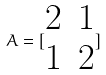<formula> <loc_0><loc_0><loc_500><loc_500>A = [ \begin{matrix} 2 & 1 \\ 1 & 2 \end{matrix} ]</formula> 